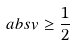Convert formula to latex. <formula><loc_0><loc_0><loc_500><loc_500>\ a b s { v } \geq \frac { 1 } { 2 }</formula> 